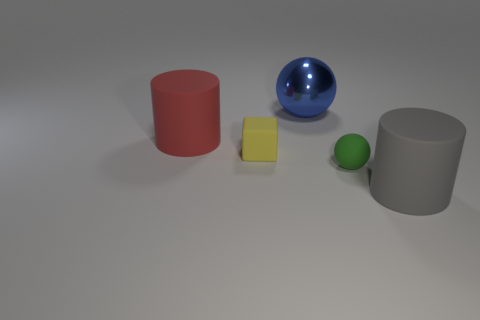How would you describe the atmosphere or mood created by the lighting and arrangement of objects in the image? The lighting in the image gives off a soft, diffuse atmosphere. The shadows are gently cast, suggesting an indirect light source. The spacing and neutral background lend the scene a serene and orderly mood, almost like a study in object composition. 